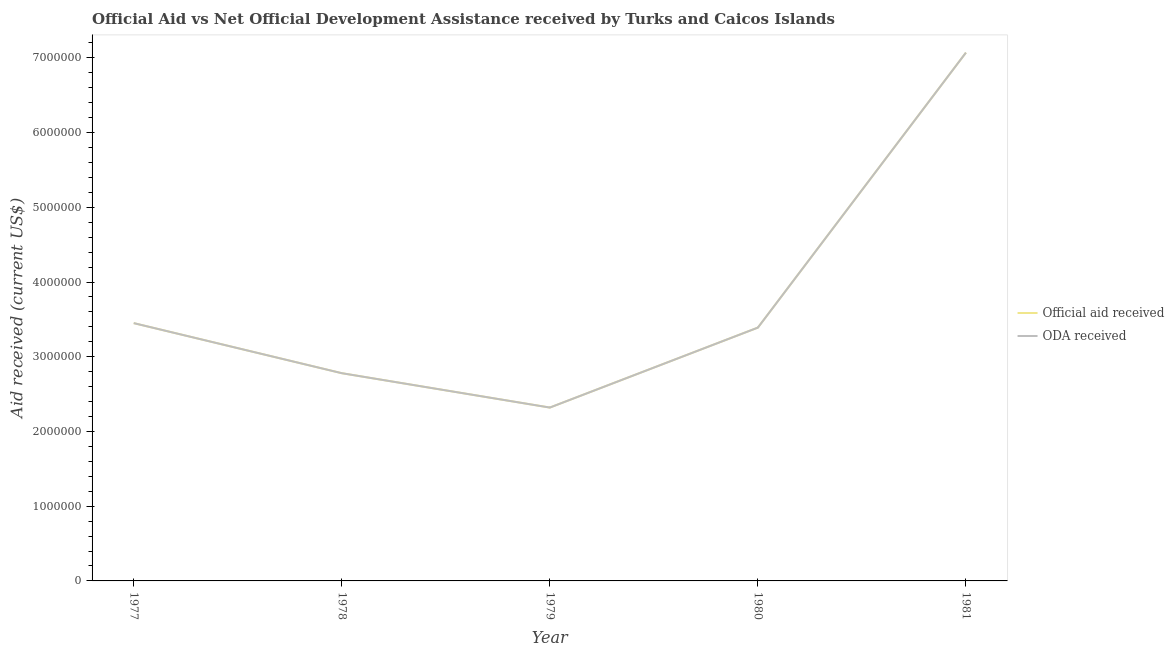Does the line corresponding to official aid received intersect with the line corresponding to oda received?
Keep it short and to the point. Yes. Is the number of lines equal to the number of legend labels?
Ensure brevity in your answer.  Yes. What is the oda received in 1981?
Provide a succinct answer. 7.07e+06. Across all years, what is the maximum official aid received?
Make the answer very short. 7.07e+06. Across all years, what is the minimum oda received?
Your answer should be compact. 2.32e+06. In which year was the official aid received maximum?
Your answer should be very brief. 1981. In which year was the official aid received minimum?
Provide a succinct answer. 1979. What is the total oda received in the graph?
Make the answer very short. 1.90e+07. What is the difference between the official aid received in 1979 and that in 1981?
Make the answer very short. -4.75e+06. What is the difference between the official aid received in 1979 and the oda received in 1977?
Keep it short and to the point. -1.13e+06. What is the average oda received per year?
Your answer should be very brief. 3.80e+06. In the year 1979, what is the difference between the official aid received and oda received?
Offer a terse response. 0. What is the ratio of the official aid received in 1980 to that in 1981?
Offer a very short reply. 0.48. Is the oda received in 1979 less than that in 1981?
Offer a terse response. Yes. What is the difference between the highest and the second highest oda received?
Keep it short and to the point. 3.62e+06. What is the difference between the highest and the lowest oda received?
Keep it short and to the point. 4.75e+06. In how many years, is the oda received greater than the average oda received taken over all years?
Provide a succinct answer. 1. Is the sum of the official aid received in 1977 and 1981 greater than the maximum oda received across all years?
Provide a succinct answer. Yes. Is the oda received strictly less than the official aid received over the years?
Offer a very short reply. No. What is the difference between two consecutive major ticks on the Y-axis?
Your response must be concise. 1.00e+06. Where does the legend appear in the graph?
Ensure brevity in your answer.  Center right. How many legend labels are there?
Give a very brief answer. 2. What is the title of the graph?
Your answer should be compact. Official Aid vs Net Official Development Assistance received by Turks and Caicos Islands . Does "Taxes" appear as one of the legend labels in the graph?
Offer a terse response. No. What is the label or title of the X-axis?
Keep it short and to the point. Year. What is the label or title of the Y-axis?
Provide a succinct answer. Aid received (current US$). What is the Aid received (current US$) in Official aid received in 1977?
Offer a very short reply. 3.45e+06. What is the Aid received (current US$) of ODA received in 1977?
Offer a very short reply. 3.45e+06. What is the Aid received (current US$) of Official aid received in 1978?
Provide a short and direct response. 2.78e+06. What is the Aid received (current US$) in ODA received in 1978?
Your response must be concise. 2.78e+06. What is the Aid received (current US$) of Official aid received in 1979?
Offer a very short reply. 2.32e+06. What is the Aid received (current US$) in ODA received in 1979?
Your answer should be compact. 2.32e+06. What is the Aid received (current US$) of Official aid received in 1980?
Your answer should be very brief. 3.39e+06. What is the Aid received (current US$) in ODA received in 1980?
Provide a succinct answer. 3.39e+06. What is the Aid received (current US$) in Official aid received in 1981?
Your answer should be compact. 7.07e+06. What is the Aid received (current US$) of ODA received in 1981?
Give a very brief answer. 7.07e+06. Across all years, what is the maximum Aid received (current US$) in Official aid received?
Offer a terse response. 7.07e+06. Across all years, what is the maximum Aid received (current US$) of ODA received?
Offer a terse response. 7.07e+06. Across all years, what is the minimum Aid received (current US$) in Official aid received?
Ensure brevity in your answer.  2.32e+06. Across all years, what is the minimum Aid received (current US$) in ODA received?
Provide a succinct answer. 2.32e+06. What is the total Aid received (current US$) in Official aid received in the graph?
Keep it short and to the point. 1.90e+07. What is the total Aid received (current US$) of ODA received in the graph?
Your response must be concise. 1.90e+07. What is the difference between the Aid received (current US$) of Official aid received in 1977 and that in 1978?
Give a very brief answer. 6.70e+05. What is the difference between the Aid received (current US$) in ODA received in 1977 and that in 1978?
Offer a terse response. 6.70e+05. What is the difference between the Aid received (current US$) in Official aid received in 1977 and that in 1979?
Give a very brief answer. 1.13e+06. What is the difference between the Aid received (current US$) in ODA received in 1977 and that in 1979?
Your answer should be very brief. 1.13e+06. What is the difference between the Aid received (current US$) in Official aid received in 1977 and that in 1981?
Your response must be concise. -3.62e+06. What is the difference between the Aid received (current US$) of ODA received in 1977 and that in 1981?
Give a very brief answer. -3.62e+06. What is the difference between the Aid received (current US$) in ODA received in 1978 and that in 1979?
Your response must be concise. 4.60e+05. What is the difference between the Aid received (current US$) of Official aid received in 1978 and that in 1980?
Make the answer very short. -6.10e+05. What is the difference between the Aid received (current US$) in ODA received in 1978 and that in 1980?
Give a very brief answer. -6.10e+05. What is the difference between the Aid received (current US$) in Official aid received in 1978 and that in 1981?
Offer a terse response. -4.29e+06. What is the difference between the Aid received (current US$) of ODA received in 1978 and that in 1981?
Make the answer very short. -4.29e+06. What is the difference between the Aid received (current US$) in Official aid received in 1979 and that in 1980?
Make the answer very short. -1.07e+06. What is the difference between the Aid received (current US$) in ODA received in 1979 and that in 1980?
Your response must be concise. -1.07e+06. What is the difference between the Aid received (current US$) in Official aid received in 1979 and that in 1981?
Give a very brief answer. -4.75e+06. What is the difference between the Aid received (current US$) of ODA received in 1979 and that in 1981?
Offer a terse response. -4.75e+06. What is the difference between the Aid received (current US$) of Official aid received in 1980 and that in 1981?
Your response must be concise. -3.68e+06. What is the difference between the Aid received (current US$) in ODA received in 1980 and that in 1981?
Keep it short and to the point. -3.68e+06. What is the difference between the Aid received (current US$) of Official aid received in 1977 and the Aid received (current US$) of ODA received in 1978?
Keep it short and to the point. 6.70e+05. What is the difference between the Aid received (current US$) of Official aid received in 1977 and the Aid received (current US$) of ODA received in 1979?
Your answer should be compact. 1.13e+06. What is the difference between the Aid received (current US$) in Official aid received in 1977 and the Aid received (current US$) in ODA received in 1981?
Ensure brevity in your answer.  -3.62e+06. What is the difference between the Aid received (current US$) in Official aid received in 1978 and the Aid received (current US$) in ODA received in 1980?
Provide a short and direct response. -6.10e+05. What is the difference between the Aid received (current US$) of Official aid received in 1978 and the Aid received (current US$) of ODA received in 1981?
Offer a very short reply. -4.29e+06. What is the difference between the Aid received (current US$) of Official aid received in 1979 and the Aid received (current US$) of ODA received in 1980?
Provide a succinct answer. -1.07e+06. What is the difference between the Aid received (current US$) of Official aid received in 1979 and the Aid received (current US$) of ODA received in 1981?
Your response must be concise. -4.75e+06. What is the difference between the Aid received (current US$) of Official aid received in 1980 and the Aid received (current US$) of ODA received in 1981?
Ensure brevity in your answer.  -3.68e+06. What is the average Aid received (current US$) of Official aid received per year?
Offer a very short reply. 3.80e+06. What is the average Aid received (current US$) of ODA received per year?
Offer a very short reply. 3.80e+06. In the year 1977, what is the difference between the Aid received (current US$) of Official aid received and Aid received (current US$) of ODA received?
Offer a very short reply. 0. In the year 1978, what is the difference between the Aid received (current US$) in Official aid received and Aid received (current US$) in ODA received?
Your answer should be compact. 0. What is the ratio of the Aid received (current US$) in Official aid received in 1977 to that in 1978?
Keep it short and to the point. 1.24. What is the ratio of the Aid received (current US$) of ODA received in 1977 to that in 1978?
Offer a terse response. 1.24. What is the ratio of the Aid received (current US$) of Official aid received in 1977 to that in 1979?
Provide a succinct answer. 1.49. What is the ratio of the Aid received (current US$) in ODA received in 1977 to that in 1979?
Ensure brevity in your answer.  1.49. What is the ratio of the Aid received (current US$) of Official aid received in 1977 to that in 1980?
Offer a very short reply. 1.02. What is the ratio of the Aid received (current US$) of ODA received in 1977 to that in 1980?
Provide a succinct answer. 1.02. What is the ratio of the Aid received (current US$) in Official aid received in 1977 to that in 1981?
Your response must be concise. 0.49. What is the ratio of the Aid received (current US$) in ODA received in 1977 to that in 1981?
Offer a very short reply. 0.49. What is the ratio of the Aid received (current US$) in Official aid received in 1978 to that in 1979?
Your answer should be compact. 1.2. What is the ratio of the Aid received (current US$) of ODA received in 1978 to that in 1979?
Keep it short and to the point. 1.2. What is the ratio of the Aid received (current US$) of Official aid received in 1978 to that in 1980?
Your response must be concise. 0.82. What is the ratio of the Aid received (current US$) of ODA received in 1978 to that in 1980?
Provide a short and direct response. 0.82. What is the ratio of the Aid received (current US$) in Official aid received in 1978 to that in 1981?
Make the answer very short. 0.39. What is the ratio of the Aid received (current US$) of ODA received in 1978 to that in 1981?
Your answer should be very brief. 0.39. What is the ratio of the Aid received (current US$) of Official aid received in 1979 to that in 1980?
Ensure brevity in your answer.  0.68. What is the ratio of the Aid received (current US$) of ODA received in 1979 to that in 1980?
Give a very brief answer. 0.68. What is the ratio of the Aid received (current US$) in Official aid received in 1979 to that in 1981?
Offer a terse response. 0.33. What is the ratio of the Aid received (current US$) of ODA received in 1979 to that in 1981?
Make the answer very short. 0.33. What is the ratio of the Aid received (current US$) of Official aid received in 1980 to that in 1981?
Offer a very short reply. 0.48. What is the ratio of the Aid received (current US$) of ODA received in 1980 to that in 1981?
Your answer should be very brief. 0.48. What is the difference between the highest and the second highest Aid received (current US$) in Official aid received?
Ensure brevity in your answer.  3.62e+06. What is the difference between the highest and the second highest Aid received (current US$) of ODA received?
Offer a terse response. 3.62e+06. What is the difference between the highest and the lowest Aid received (current US$) of Official aid received?
Your answer should be compact. 4.75e+06. What is the difference between the highest and the lowest Aid received (current US$) in ODA received?
Give a very brief answer. 4.75e+06. 